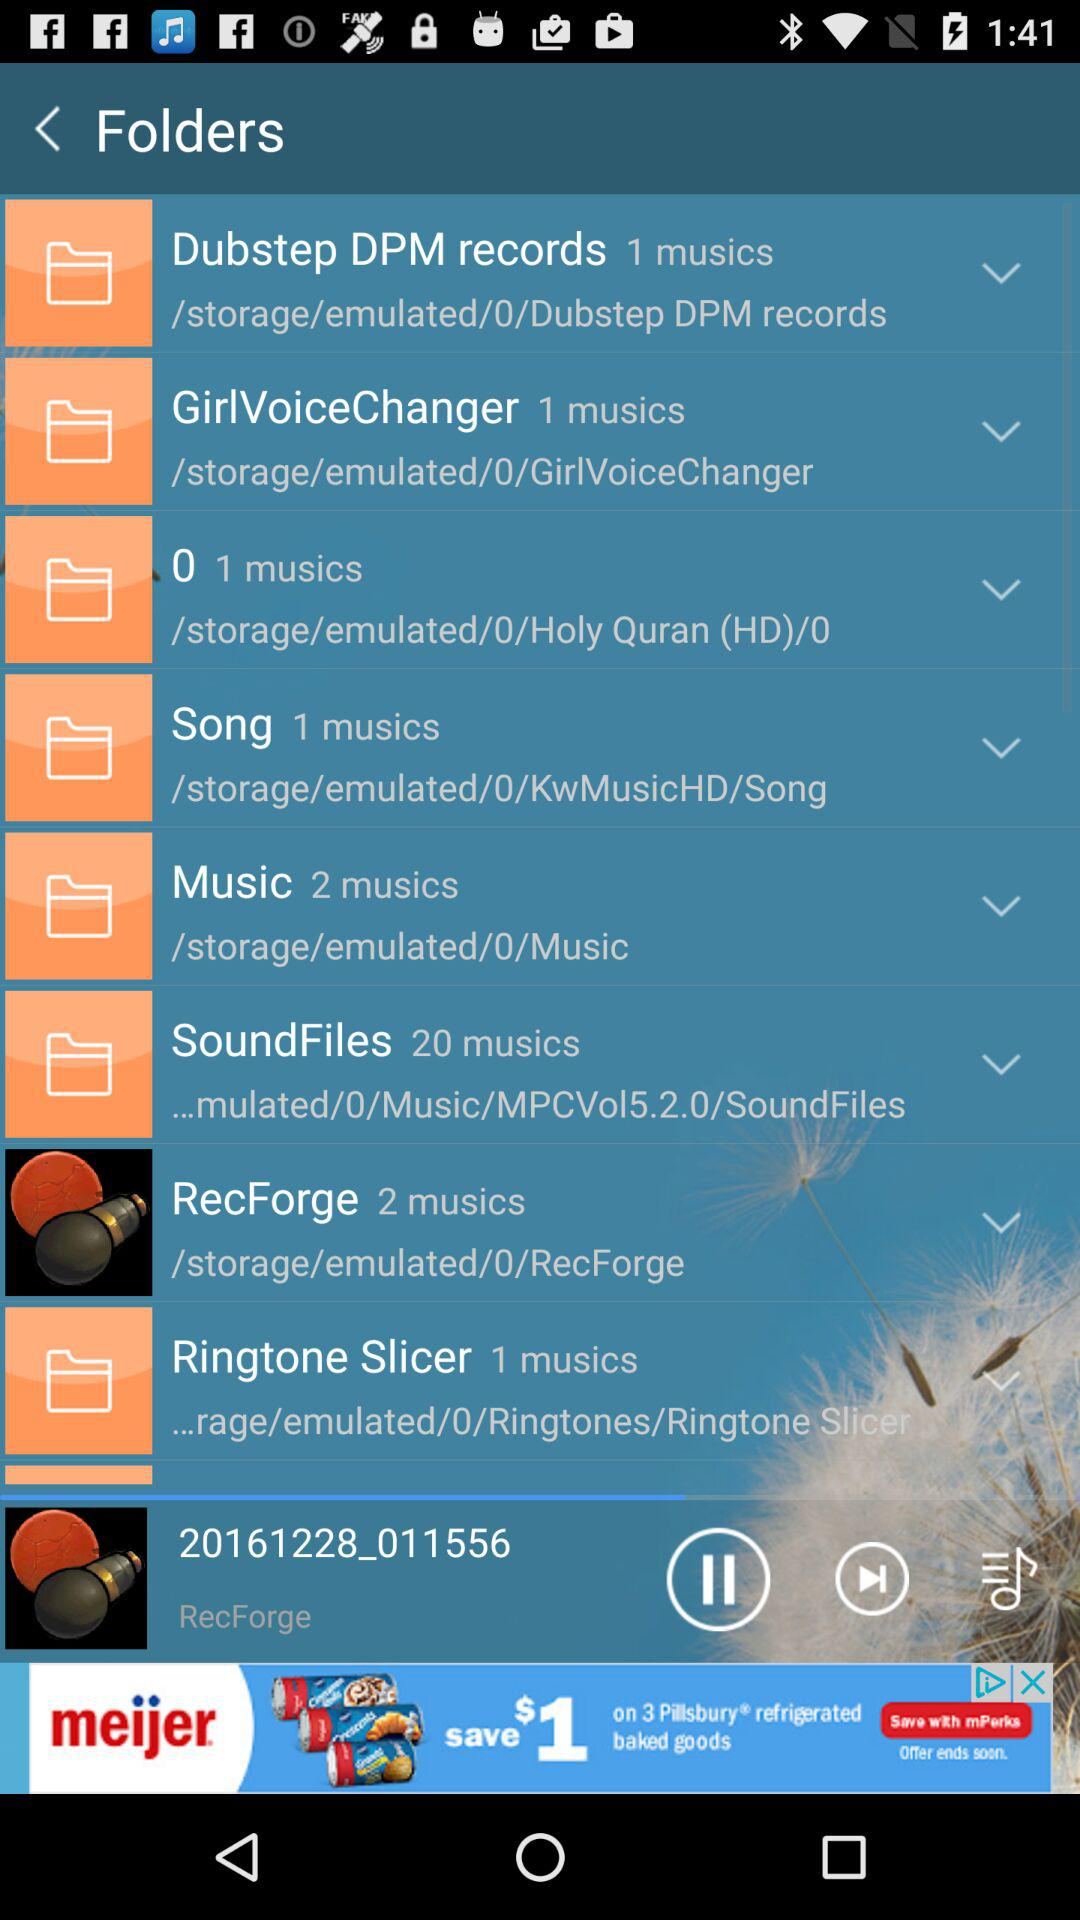How many music are in the "Ringtone Slicer" folder? There is 1 music in the "Ringtone Slicer" folder. 